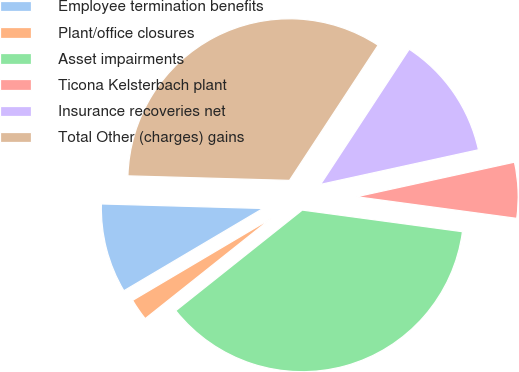<chart> <loc_0><loc_0><loc_500><loc_500><pie_chart><fcel>Employee termination benefits<fcel>Plant/office closures<fcel>Asset impairments<fcel>Ticona Kelsterbach plant<fcel>Insurance recoveries net<fcel>Total Other (charges) gains<nl><fcel>8.95%<fcel>2.19%<fcel>37.17%<fcel>5.57%<fcel>12.33%<fcel>33.79%<nl></chart> 